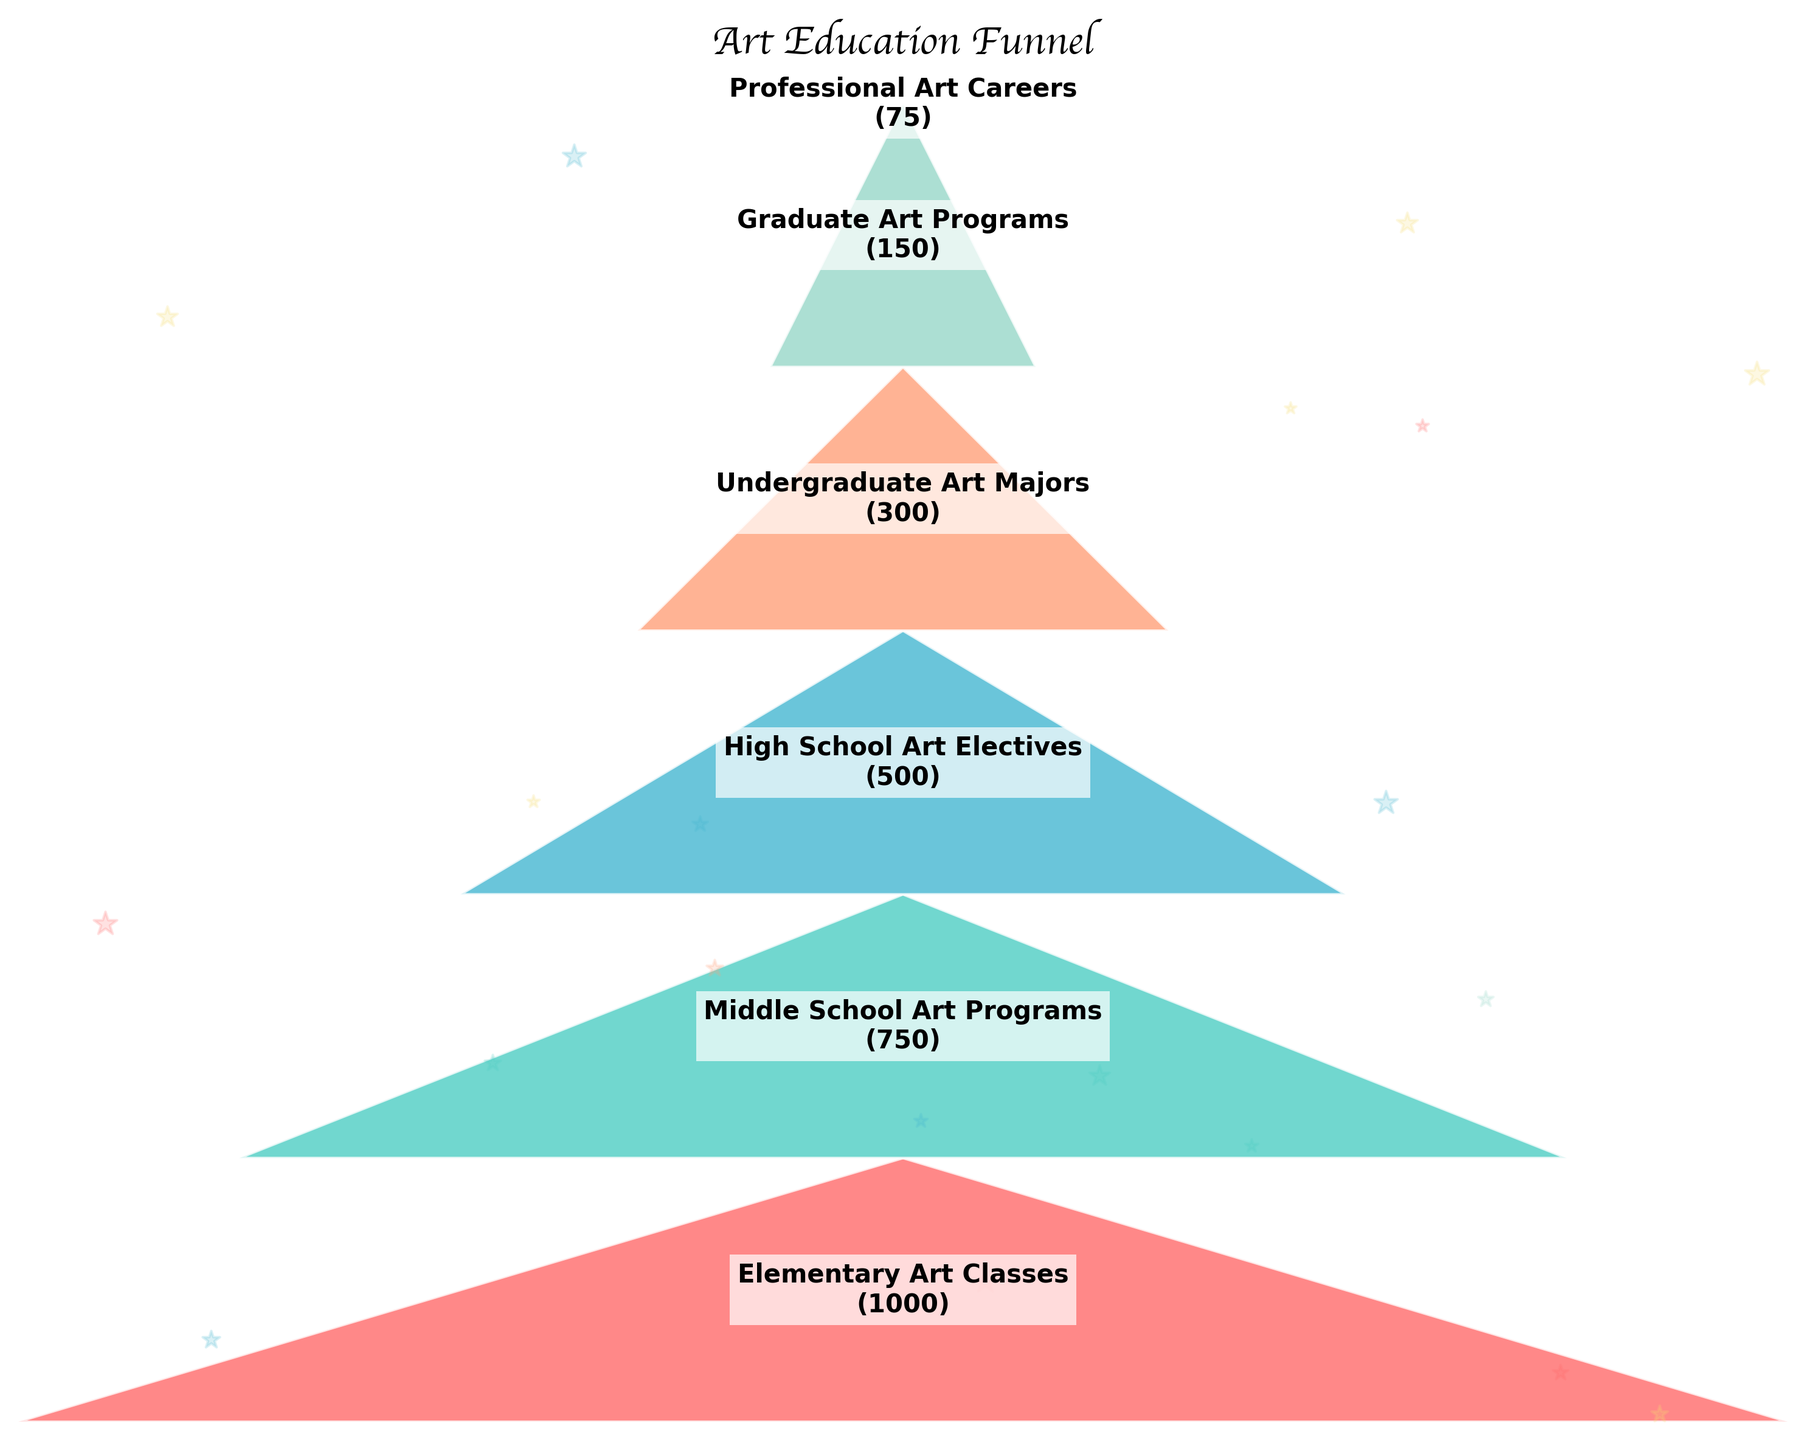What is the title of the figure? The title of the figure is usually found at the top and is intended to briefly describe the content or purpose of the chart. In this case, it’s written in a bold, cursive font.
Answer: Art Education Funnel How many stages are there in the funnel chart? To determine this, count the number of distinct stages listed from top to bottom in the chart.
Answer: 6 Which stage has the highest number of students? Locate the stage with the widest section at the top of the funnel, which corresponds to the highest number of students.
Answer: Elementary Art Classes What is the number of students in the Graduate Art Programs stage? Look for the section labeled "Graduate Art Programs" and note the student count given next to it.
Answer: 150 How many more students are there in Middle School Art Programs compared to High School Art Electives? Find the student numbers for both stages and calculate the difference. Middle School Art Programs has 750 students, and High School Art Electives has 500 students. The difference is 750 - 500.
Answer: 250 Are there more students in Undergraduate Art Majors or Professional Art Careers? By how many? Compare the student numbers of both stages. Undergraduate Art Majors has 300 students, while Professional Art Careers has 75. Subtract the smaller number from the larger number (300 - 75).
Answer: Undergraduate Art Majors, 225 What is the trend observed as students progress through different levels of art education? Observe how the width of the funnel sections decreases from top to bottom, indicating a reduction in student numbers at each subsequent stage.
Answer: Decreasing What percentage of students from Elementary Art Classes continue to Middle School Art Programs? Calculate the percentage by dividing the number of students in Middle School Art Programs by the number of students in Elementary Art Classes and then multiplying by 100. That is (750 / 1000) * 100.
Answer: 75% What is the ratio of students in High School Art Electives to Graduate Art Programs? Divide the number of students in High School Art Electives by the number of students in Graduate Art Programs: 500 / 150.
Answer: 10:3 Do more students drop out between High School Art Electives and Undergraduate Art Majors or between Undergraduate Art Majors and Graduate Art Programs? Compare the differences in student numbers between these stages. High School Art Electives to Undergraduate Art Majors is 500 - 300 = 200, while Undergraduate Art Majors to Graduate Art Programs is 300 - 150 = 150.
Answer: High School Art Electives to Undergraduate Art Majors 